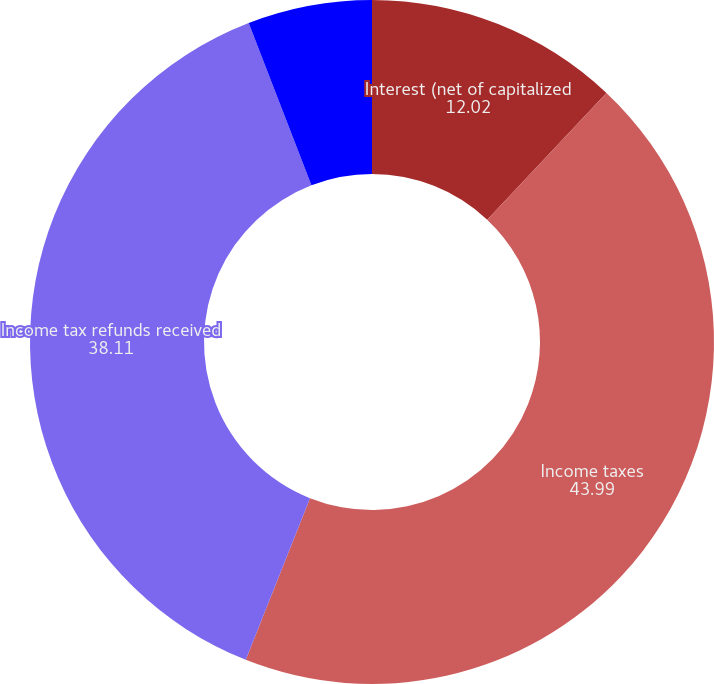Convert chart. <chart><loc_0><loc_0><loc_500><loc_500><pie_chart><fcel>Interest (net of capitalized<fcel>Income taxes<fcel>Income tax refunds received<fcel>Cash tax payments net<nl><fcel>12.02%<fcel>43.99%<fcel>38.11%<fcel>5.87%<nl></chart> 